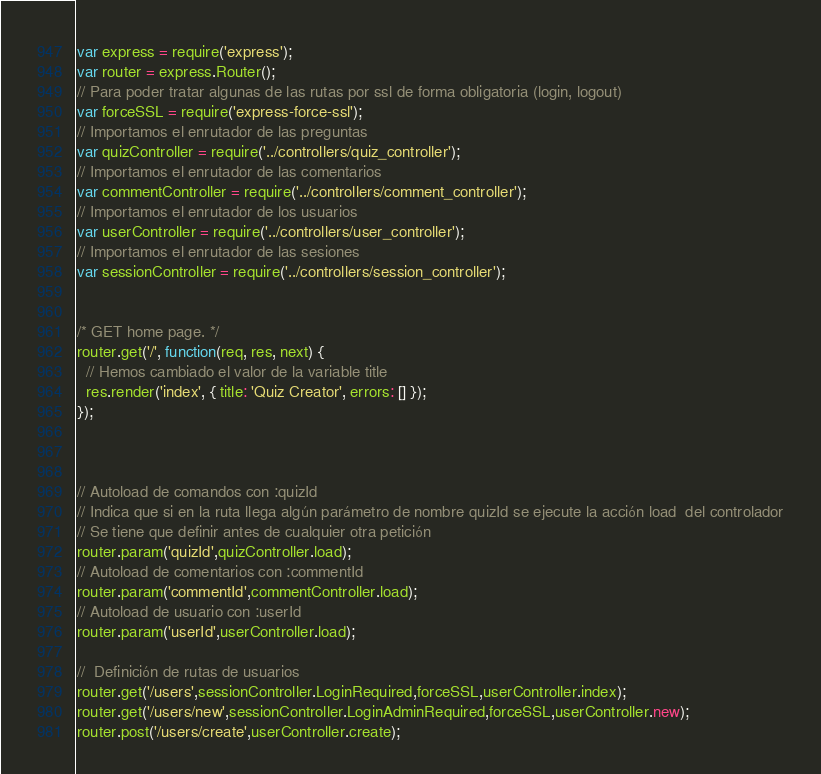<code> <loc_0><loc_0><loc_500><loc_500><_JavaScript_>var express = require('express');
var router = express.Router();
// Para poder tratar algunas de las rutas por ssl de forma obligatoria (login, logout)
var forceSSL = require('express-force-ssl');
// Importamos el enrutador de las preguntas
var quizController = require('../controllers/quiz_controller');
// Importamos el enrutador de las comentarios
var commentController = require('../controllers/comment_controller');
// Importamos el enrutador de los usuarios
var userController = require('../controllers/user_controller');
// Importamos el enrutador de las sesiones
var sessionController = require('../controllers/session_controller');


/* GET home page. */
router.get('/', function(req, res, next) {
  // Hemos cambiado el valor de la variable title
  res.render('index', { title: 'Quiz Creator', errors: [] });
});



// Autoload de comandos con :quizId
// Indica que si en la ruta llega algún parámetro de nombre quizId se ejecute la acción load  del controlador
// Se tiene que definir antes de cualquier otra petición
router.param('quizId',quizController.load);
// Autoload de comentarios con :commentId
router.param('commentId',commentController.load);
// Autoload de usuario con :userId
router.param('userId',userController.load);

//  Definición de rutas de usuarios
router.get('/users',sessionController.LoginRequired,forceSSL,userController.index);
router.get('/users/new',sessionController.LoginAdminRequired,forceSSL,userController.new);
router.post('/users/create',userController.create);</code> 